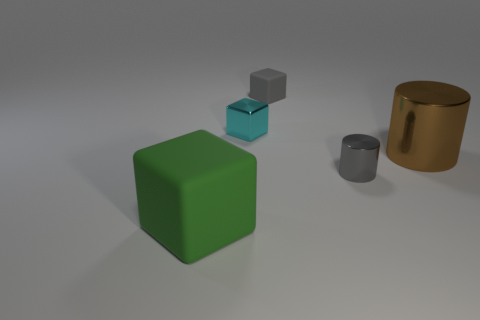Subtract all tiny blocks. How many blocks are left? 1 Add 4 big brown shiny objects. How many objects exist? 9 Subtract all brown cylinders. How many cylinders are left? 1 Add 5 large yellow matte things. How many large yellow matte things exist? 5 Subtract 1 cyan cubes. How many objects are left? 4 Subtract all blocks. How many objects are left? 2 Subtract all brown cylinders. Subtract all yellow balls. How many cylinders are left? 1 Subtract all gray cubes. How many brown cylinders are left? 1 Subtract all small gray metal things. Subtract all green blocks. How many objects are left? 3 Add 5 tiny cubes. How many tiny cubes are left? 7 